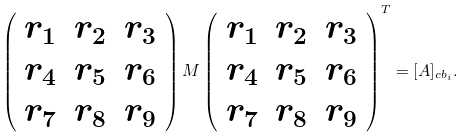Convert formula to latex. <formula><loc_0><loc_0><loc_500><loc_500>\left ( \begin{array} { l l l } r _ { 1 } & r _ { 2 } & r _ { 3 } \\ r _ { 4 } & r _ { 5 } & r _ { 6 } \\ r _ { 7 } & r _ { 8 } & r _ { 9 } \end{array} \right ) M \left ( \begin{array} { l l l } r _ { 1 } & r _ { 2 } & r _ { 3 } \\ r _ { 4 } & r _ { 5 } & r _ { 6 } \\ r _ { 7 } & r _ { 8 } & r _ { 9 } \end{array} \right ) ^ { T } = [ A ] _ { c b _ { i } } .</formula> 